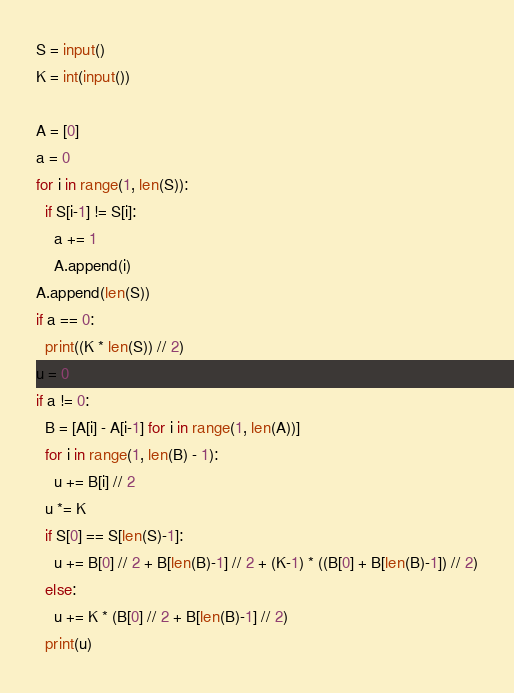<code> <loc_0><loc_0><loc_500><loc_500><_Python_>S = input()
K = int(input())

A = [0]
a = 0
for i in range(1, len(S)):
  if S[i-1] != S[i]:
    a += 1
    A.append(i)
A.append(len(S))
if a == 0:
  print((K * len(S)) // 2)
u = 0
if a != 0:
  B = [A[i] - A[i-1] for i in range(1, len(A))]
  for i in range(1, len(B) - 1):
    u += B[i] // 2
  u *= K
  if S[0] == S[len(S)-1]:
    u += B[0] // 2 + B[len(B)-1] // 2 + (K-1) * ((B[0] + B[len(B)-1]) // 2)
  else:
    u += K * (B[0] // 2 + B[len(B)-1] // 2)
  print(u)</code> 